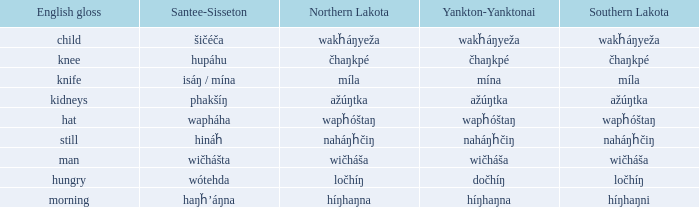Name the southern lakota for híŋhaŋna Híŋhaŋni. 